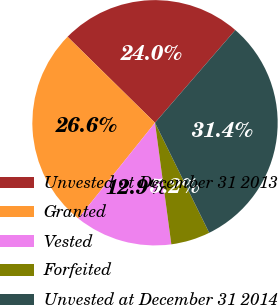Convert chart to OTSL. <chart><loc_0><loc_0><loc_500><loc_500><pie_chart><fcel>Unvested at December 31 2013<fcel>Granted<fcel>Vested<fcel>Forfeited<fcel>Unvested at December 31 2014<nl><fcel>23.99%<fcel>26.61%<fcel>12.88%<fcel>5.16%<fcel>31.36%<nl></chart> 